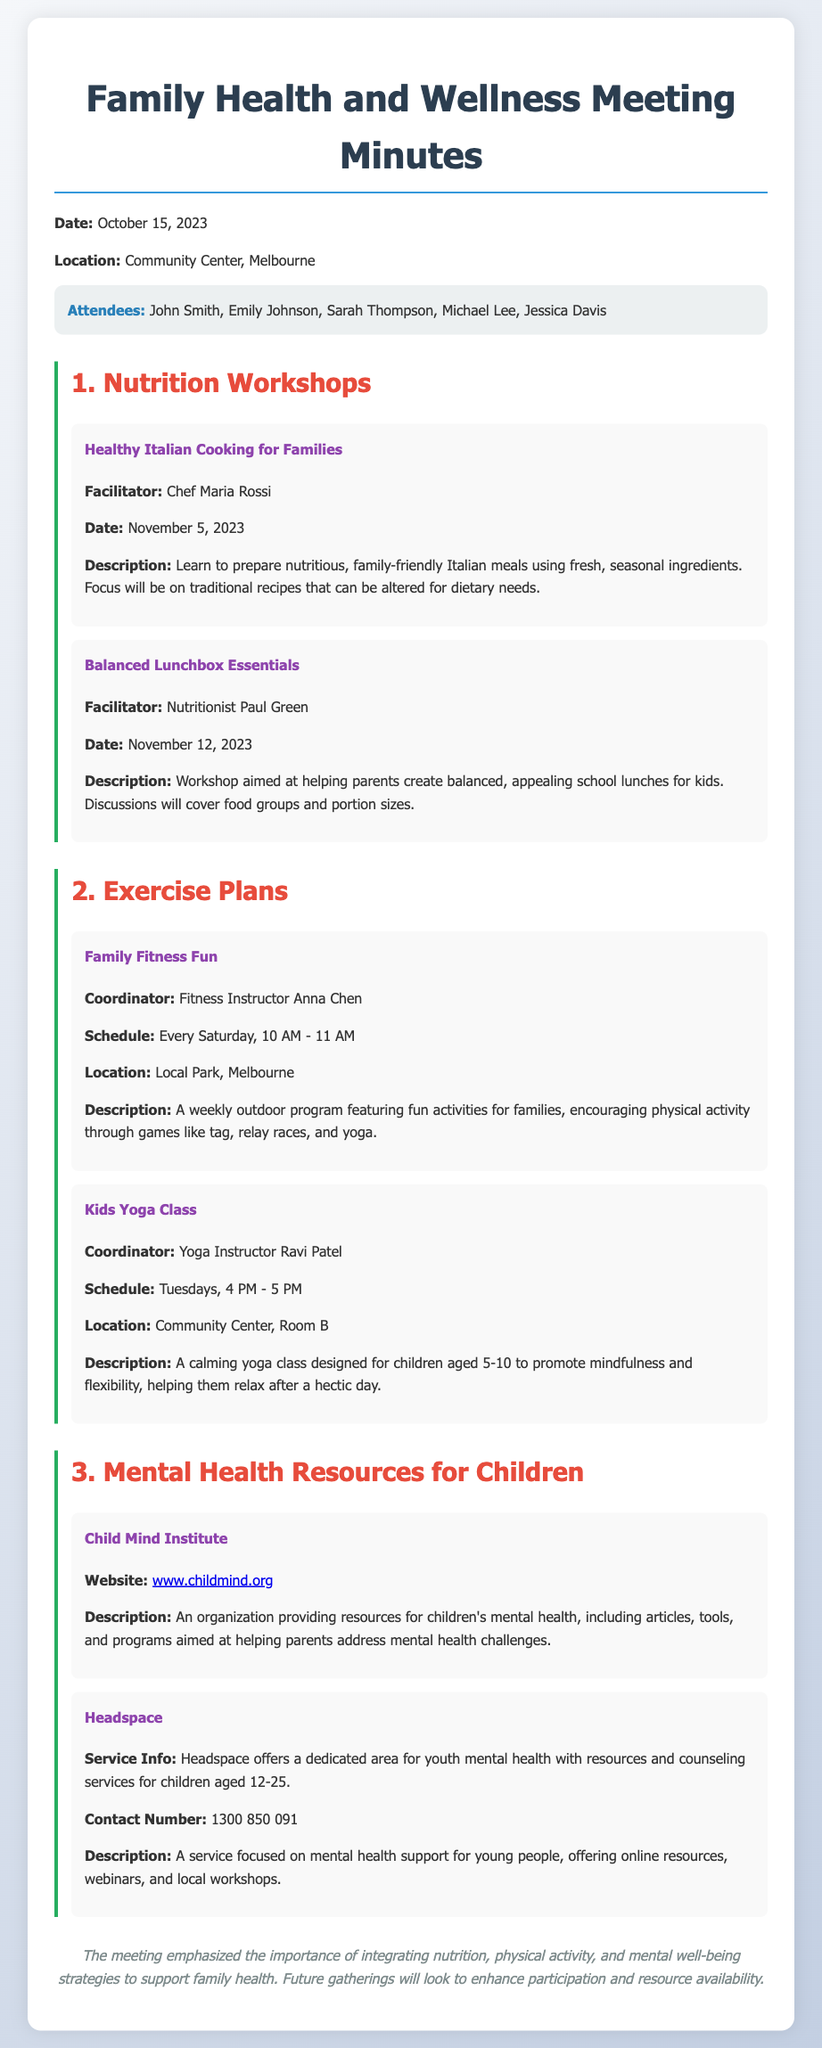What is the date of the meeting? The date of the meeting is provided in the document as October 15, 2023.
Answer: October 15, 2023 Who facilitated the "Healthy Italian Cooking for Families" workshop? The document states that Chef Maria Rossi facilitated the workshop.
Answer: Chef Maria Rossi What is the location for the "Kids Yoga Class"? The location for the "Kids Yoga Class" is mentioned as Community Center, Room B.
Answer: Community Center, Room B How often does the "Family Fitness Fun" program occur? The document describes that the "Family Fitness Fun" program is scheduled every Saturday.
Answer: Every Saturday What age group is the Kids Yoga Class designed for? The document indicates that the Kids Yoga Class is for children aged 5-10.
Answer: 5-10 How many workshops were mentioned in the Nutrition section? The document lists a total of two workshops in the Nutrition section.
Answer: Two What type of resources does the Child Mind Institute provide? The document mentions that Child Mind Institute provides resources for children's mental health.
Answer: Children's mental health When is the "Balanced Lunchbox Essentials" workshop scheduled? The workshop is scheduled for November 12, 2023, as stated in the document.
Answer: November 12, 2023 What is the contact number for Headspace? The document specifies the contact number for Headspace as 1300 850 091.
Answer: 1300 850 091 